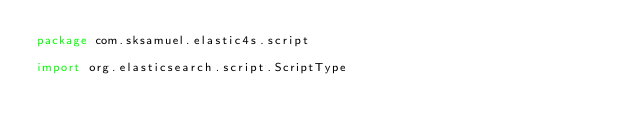Convert code to text. <code><loc_0><loc_0><loc_500><loc_500><_Scala_>package com.sksamuel.elastic4s.script

import org.elasticsearch.script.ScriptType
</code> 